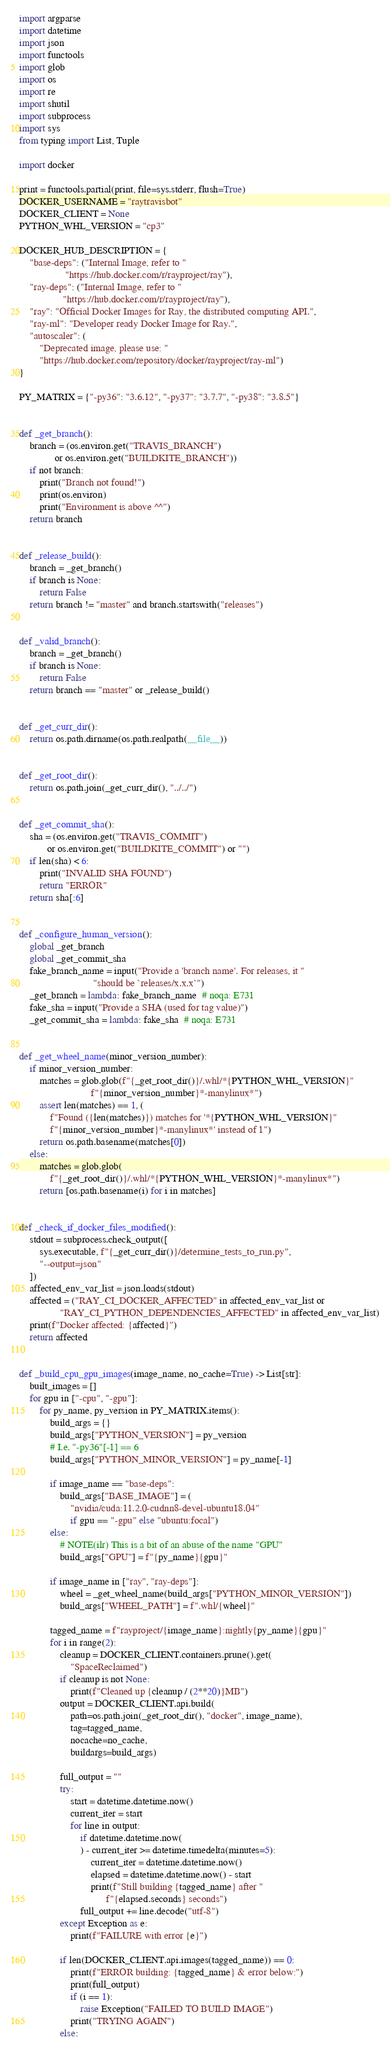Convert code to text. <code><loc_0><loc_0><loc_500><loc_500><_Python_>import argparse
import datetime
import json
import functools
import glob
import os
import re
import shutil
import subprocess
import sys
from typing import List, Tuple

import docker

print = functools.partial(print, file=sys.stderr, flush=True)
DOCKER_USERNAME = "raytravisbot"
DOCKER_CLIENT = None
PYTHON_WHL_VERSION = "cp3"

DOCKER_HUB_DESCRIPTION = {
    "base-deps": ("Internal Image, refer to "
                  "https://hub.docker.com/r/rayproject/ray"),
    "ray-deps": ("Internal Image, refer to "
                 "https://hub.docker.com/r/rayproject/ray"),
    "ray": "Official Docker Images for Ray, the distributed computing API.",
    "ray-ml": "Developer ready Docker Image for Ray.",
    "autoscaler": (
        "Deprecated image, please use: "
        "https://hub.docker.com/repository/docker/rayproject/ray-ml")
}

PY_MATRIX = {"-py36": "3.6.12", "-py37": "3.7.7", "-py38": "3.8.5"}


def _get_branch():
    branch = (os.environ.get("TRAVIS_BRANCH")
              or os.environ.get("BUILDKITE_BRANCH"))
    if not branch:
        print("Branch not found!")
        print(os.environ)
        print("Environment is above ^^")
    return branch


def _release_build():
    branch = _get_branch()
    if branch is None:
        return False
    return branch != "master" and branch.startswith("releases")


def _valid_branch():
    branch = _get_branch()
    if branch is None:
        return False
    return branch == "master" or _release_build()


def _get_curr_dir():
    return os.path.dirname(os.path.realpath(__file__))


def _get_root_dir():
    return os.path.join(_get_curr_dir(), "../../")


def _get_commit_sha():
    sha = (os.environ.get("TRAVIS_COMMIT")
           or os.environ.get("BUILDKITE_COMMIT") or "")
    if len(sha) < 6:
        print("INVALID SHA FOUND")
        return "ERROR"
    return sha[:6]


def _configure_human_version():
    global _get_branch
    global _get_commit_sha
    fake_branch_name = input("Provide a 'branch name'. For releases, it "
                             "should be `releases/x.x.x`")
    _get_branch = lambda: fake_branch_name  # noqa: E731
    fake_sha = input("Provide a SHA (used for tag value)")
    _get_commit_sha = lambda: fake_sha  # noqa: E731


def _get_wheel_name(minor_version_number):
    if minor_version_number:
        matches = glob.glob(f"{_get_root_dir()}/.whl/*{PYTHON_WHL_VERSION}"
                            f"{minor_version_number}*-manylinux*")
        assert len(matches) == 1, (
            f"Found ({len(matches)}) matches for '*{PYTHON_WHL_VERSION}"
            f"{minor_version_number}*-manylinux*' instead of 1")
        return os.path.basename(matches[0])
    else:
        matches = glob.glob(
            f"{_get_root_dir()}/.whl/*{PYTHON_WHL_VERSION}*-manylinux*")
        return [os.path.basename(i) for i in matches]


def _check_if_docker_files_modified():
    stdout = subprocess.check_output([
        sys.executable, f"{_get_curr_dir()}/determine_tests_to_run.py",
        "--output=json"
    ])
    affected_env_var_list = json.loads(stdout)
    affected = ("RAY_CI_DOCKER_AFFECTED" in affected_env_var_list or
                "RAY_CI_PYTHON_DEPENDENCIES_AFFECTED" in affected_env_var_list)
    print(f"Docker affected: {affected}")
    return affected


def _build_cpu_gpu_images(image_name, no_cache=True) -> List[str]:
    built_images = []
    for gpu in ["-cpu", "-gpu"]:
        for py_name, py_version in PY_MATRIX.items():
            build_args = {}
            build_args["PYTHON_VERSION"] = py_version
            # I.e. "-py36"[-1] == 6
            build_args["PYTHON_MINOR_VERSION"] = py_name[-1]

            if image_name == "base-deps":
                build_args["BASE_IMAGE"] = (
                    "nvidia/cuda:11.2.0-cudnn8-devel-ubuntu18.04"
                    if gpu == "-gpu" else "ubuntu:focal")
            else:
                # NOTE(ilr) This is a bit of an abuse of the name "GPU"
                build_args["GPU"] = f"{py_name}{gpu}"

            if image_name in ["ray", "ray-deps"]:
                wheel = _get_wheel_name(build_args["PYTHON_MINOR_VERSION"])
                build_args["WHEEL_PATH"] = f".whl/{wheel}"

            tagged_name = f"rayproject/{image_name}:nightly{py_name}{gpu}"
            for i in range(2):
                cleanup = DOCKER_CLIENT.containers.prune().get(
                    "SpaceReclaimed")
                if cleanup is not None:
                    print(f"Cleaned up {cleanup / (2**20)}MB")
                output = DOCKER_CLIENT.api.build(
                    path=os.path.join(_get_root_dir(), "docker", image_name),
                    tag=tagged_name,
                    nocache=no_cache,
                    buildargs=build_args)

                full_output = ""
                try:
                    start = datetime.datetime.now()
                    current_iter = start
                    for line in output:
                        if datetime.datetime.now(
                        ) - current_iter >= datetime.timedelta(minutes=5):
                            current_iter = datetime.datetime.now()
                            elapsed = datetime.datetime.now() - start
                            print(f"Still building {tagged_name} after "
                                  f"{elapsed.seconds} seconds")
                        full_output += line.decode("utf-8")
                except Exception as e:
                    print(f"FAILURE with error {e}")

                if len(DOCKER_CLIENT.api.images(tagged_name)) == 0:
                    print(f"ERROR building: {tagged_name} & error below:")
                    print(full_output)
                    if (i == 1):
                        raise Exception("FAILED TO BUILD IMAGE")
                    print("TRYING AGAIN")
                else:</code> 